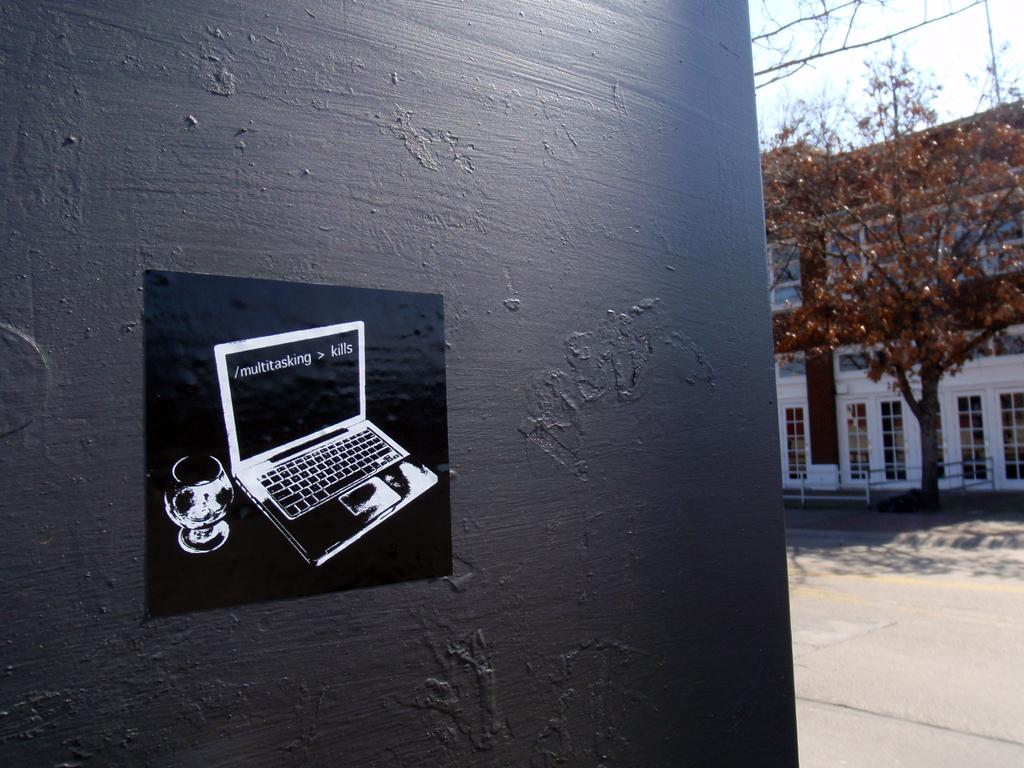<image>
Write a terse but informative summary of the picture. Laptop sticker on a black wall outside saying Multitasking > kills. 